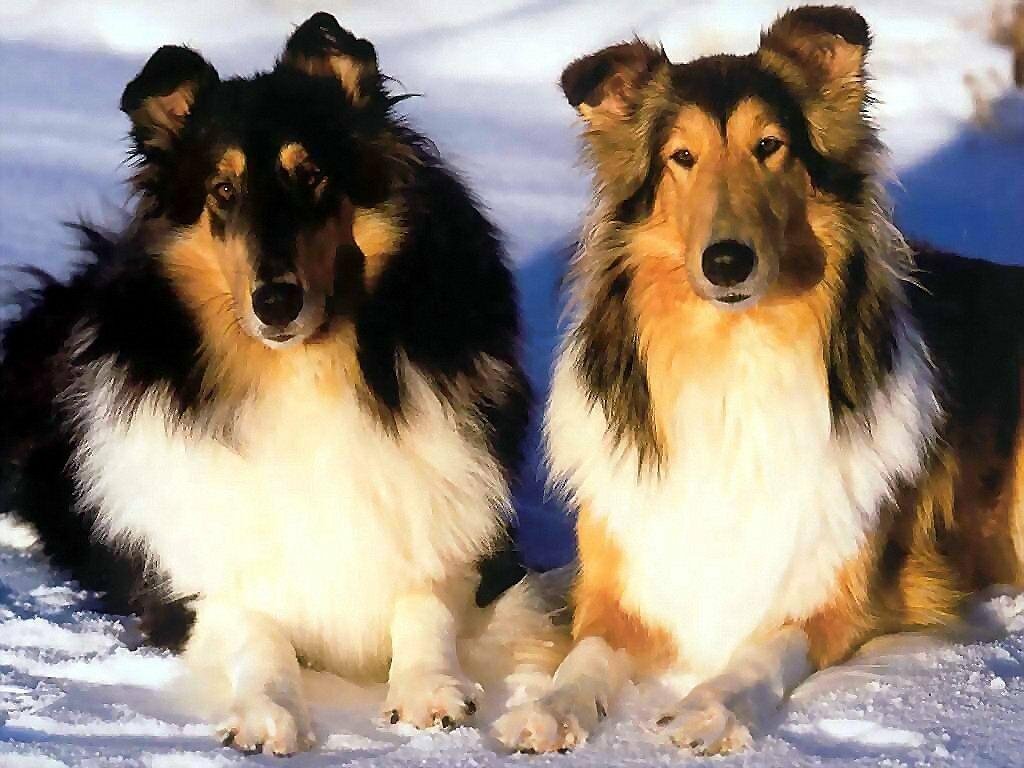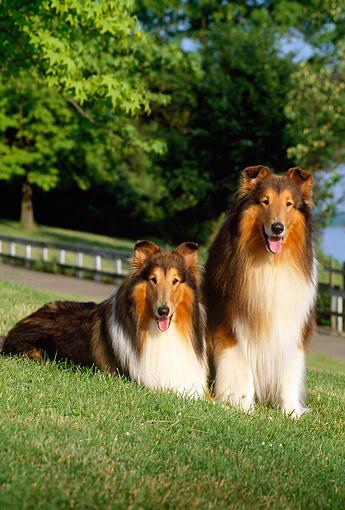The first image is the image on the left, the second image is the image on the right. Evaluate the accuracy of this statement regarding the images: "An image shows exactly two collie dogs posed outdoors, with one reclining at the left of a dog sitting upright.". Is it true? Answer yes or no. Yes. 